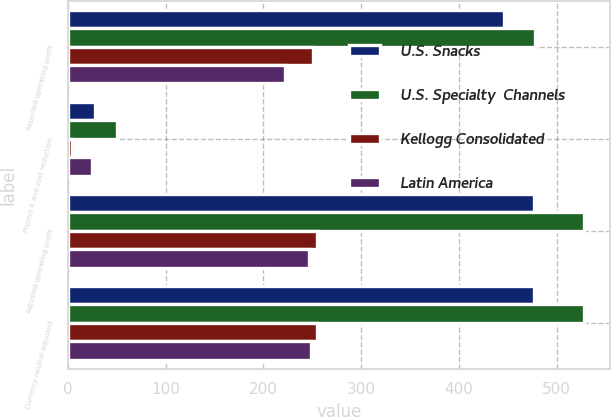Convert chart. <chart><loc_0><loc_0><loc_500><loc_500><stacked_bar_chart><ecel><fcel>Reported operating profit<fcel>Project K and cost reduction<fcel>Adjusted operating profit<fcel>Currency-neutral adjusted<nl><fcel>U.S. Snacks<fcel>446<fcel>28<fcel>477<fcel>477<nl><fcel>U.S. Specialty  Channels<fcel>478<fcel>50<fcel>528<fcel>528<nl><fcel>Kellogg Consolidated<fcel>251<fcel>4<fcel>255<fcel>255<nl><fcel>Latin America<fcel>222<fcel>25<fcel>247<fcel>249<nl></chart> 